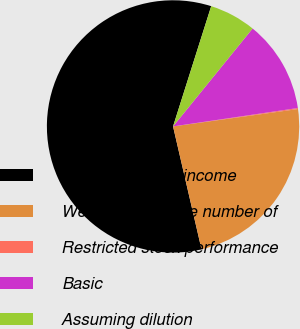<chart> <loc_0><loc_0><loc_500><loc_500><pie_chart><fcel>Numerator - net income<fcel>Weighted-average number of<fcel>Restricted stock performance<fcel>Basic<fcel>Assuming dilution<nl><fcel>58.52%<fcel>23.58%<fcel>0.13%<fcel>11.81%<fcel>5.97%<nl></chart> 